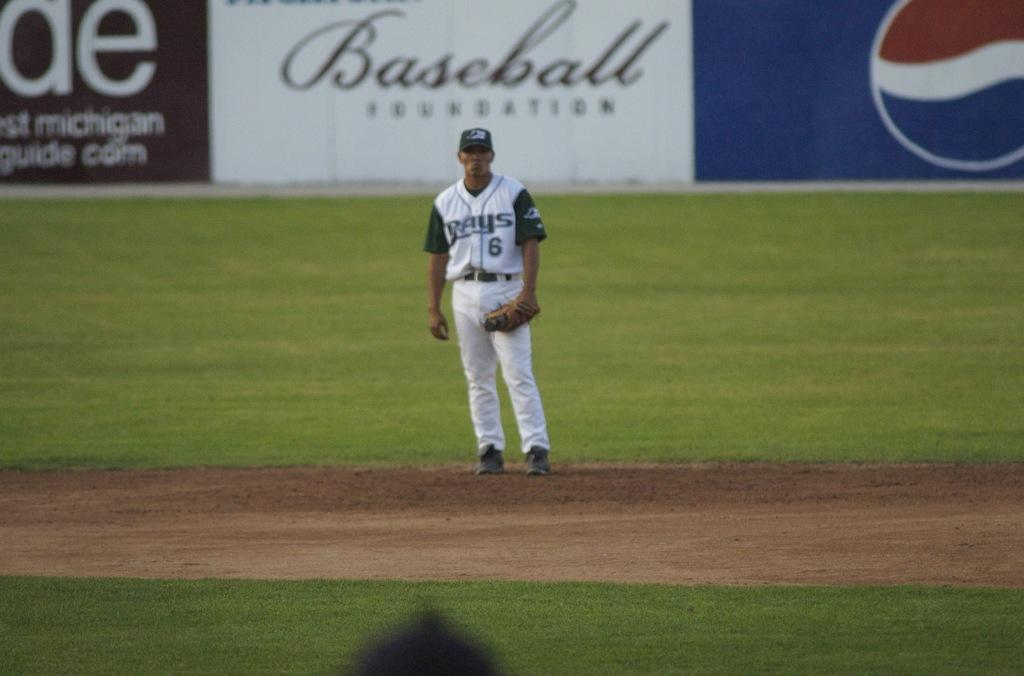<image>
Describe the image concisely. A baseball player in a Rays uniform stands on the field. 